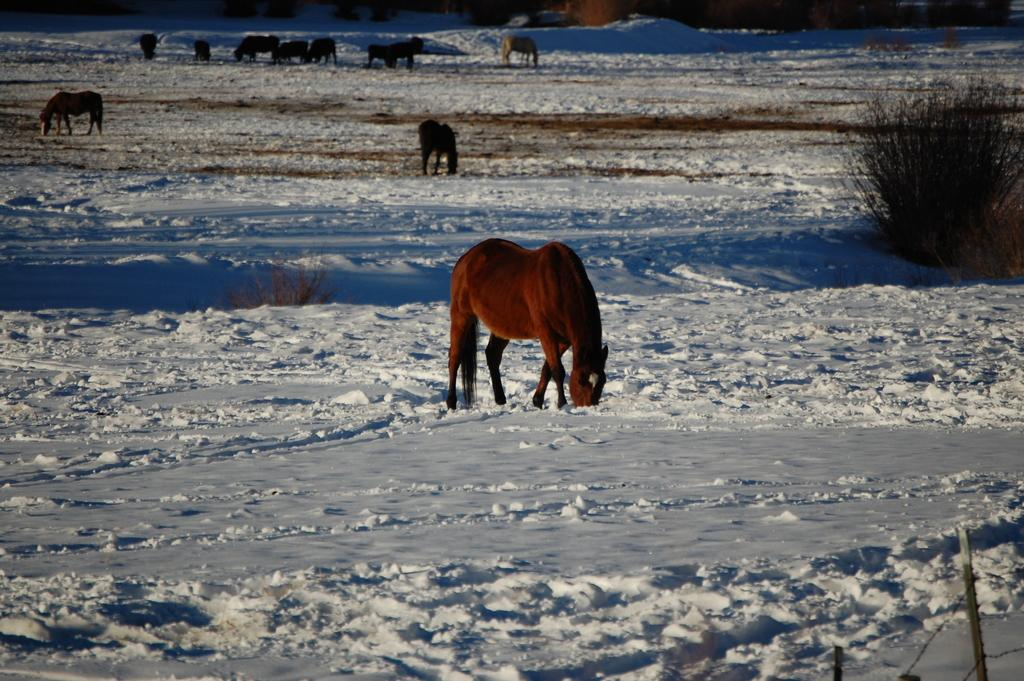What types of living organisms can be seen in the image? There are animals in the image. What type of vegetation is on the right side of the image? There are shrubs on the right side of the image. What type of paper can be seen in the image? There is no paper present in the image. Can you see any snails in the image? There is no snail present in the image. 